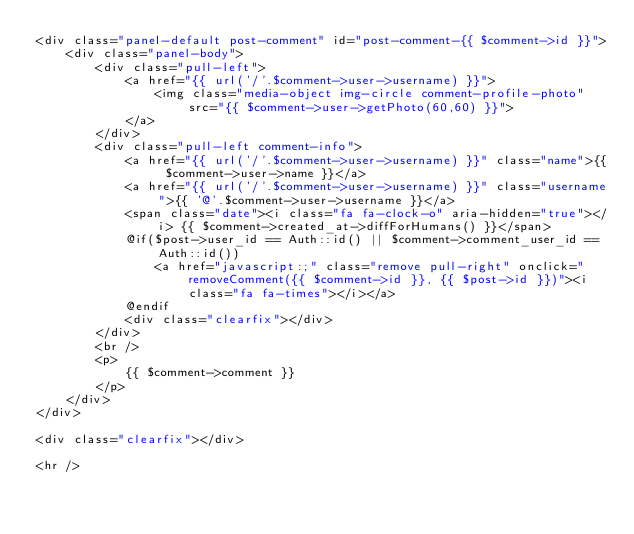<code> <loc_0><loc_0><loc_500><loc_500><_PHP_><div class="panel-default post-comment" id="post-comment-{{ $comment->id }}">
    <div class="panel-body">
        <div class="pull-left">
            <a href="{{ url('/'.$comment->user->username) }}">
                <img class="media-object img-circle comment-profile-photo" src="{{ $comment->user->getPhoto(60,60) }}">
            </a>
        </div>
        <div class="pull-left comment-info">
            <a href="{{ url('/'.$comment->user->username) }}" class="name">{{ $comment->user->name }}</a>
            <a href="{{ url('/'.$comment->user->username) }}" class="username">{{ '@'.$comment->user->username }}</a>
            <span class="date"><i class="fa fa-clock-o" aria-hidden="true"></i> {{ $comment->created_at->diffForHumans() }}</span>
            @if($post->user_id == Auth::id() || $comment->comment_user_id == Auth::id())
                <a href="javascript:;" class="remove pull-right" onclick="removeComment({{ $comment->id }}, {{ $post->id }})"><i class="fa fa-times"></i></a>
            @endif
            <div class="clearfix"></div>
        </div>
        <br />
        <p>
            {{ $comment->comment }}
        </p>
    </div>
</div>

<div class="clearfix"></div>

<hr /></code> 